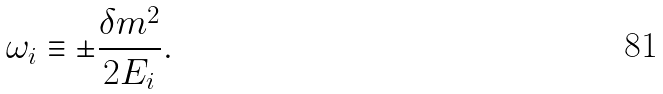Convert formula to latex. <formula><loc_0><loc_0><loc_500><loc_500>\omega _ { i } \equiv \pm \frac { \delta m ^ { 2 } } { 2 E _ { i } } .</formula> 